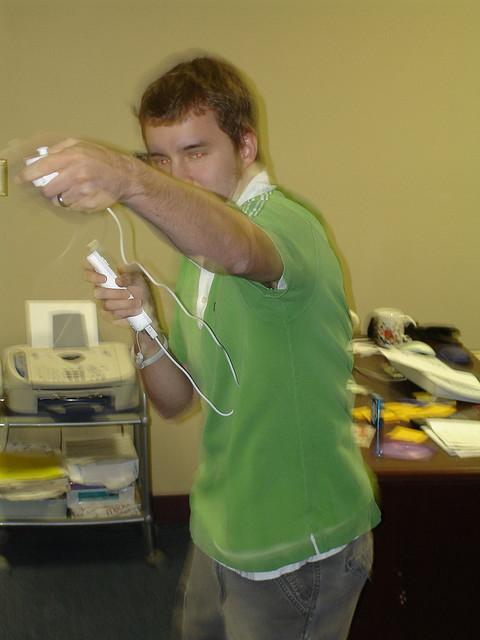What office equipment is on the shelf? Please explain your reasoning. fax. The office equipment is an electronic device the size of a printer that has far more buttons than a printer and has an input and output for printer paper. 